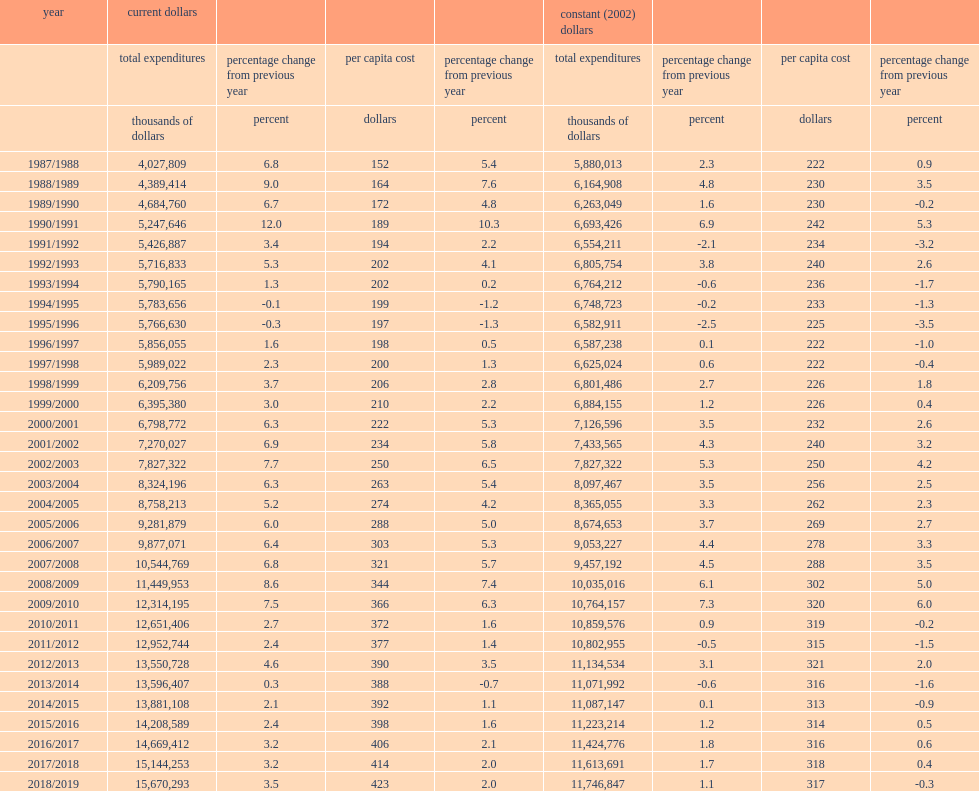How much is the 2018/2019 total operating expenditures for all police services in current dollars? 15670293.0. On a per capita basis for canada, using constant dollars, how much is the policing operating expenditures per person in 2018/2019? 317.0. 